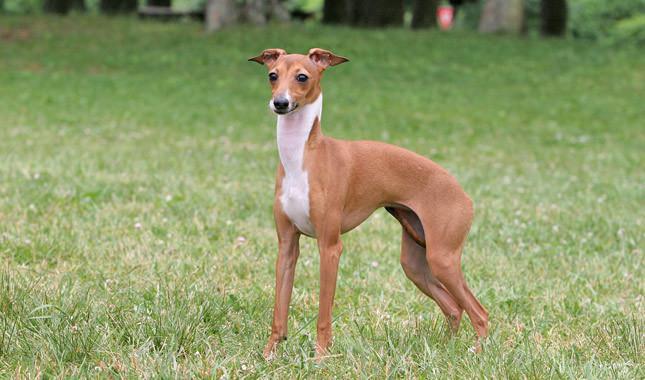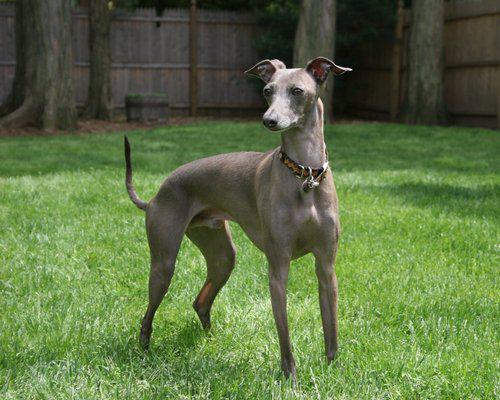The first image is the image on the left, the second image is the image on the right. Considering the images on both sides, is "there is a gray dog standing with its body facing right" valid? Answer yes or no. Yes. 